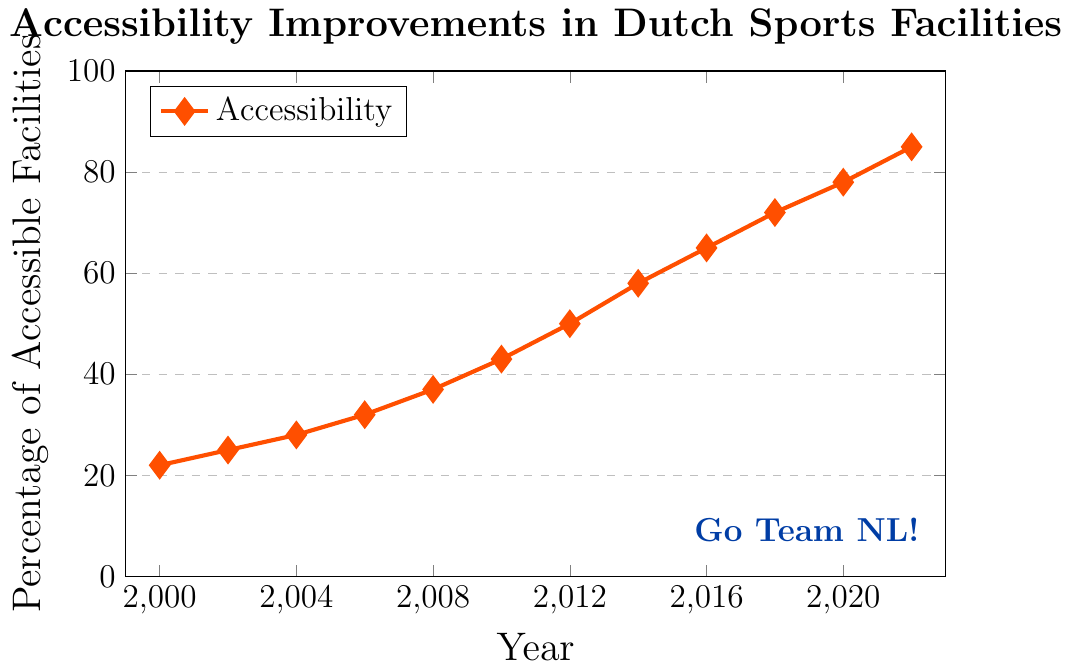What's the percentage increase in accessible sports facilities from 2000 to 2022? First, find the percentage of accessible sports facilities in 2000, which is 22%. Next, find the percentage in 2022, which is 85%. Subtract the 2000 value from the 2022 value to get the increase: 85 - 22 = 63.
Answer: 63 What is the average percentage of accessible sports facilities for the years 2000, 2010, and 2020? Find the percentages for the years 2000, 2010, and 2020: 22%, 43%, and 78%. Sum them up: 22 + 43 + 78 = 143. There are 3 years, so divide the total by 3 for the average: 143 / 3 ≈ 47.67.
Answer: 47.67 Which year had the highest percentage increase in accessible sports facilities compared to the previous data point? Calculate the year-on-year increases: 2002-2000: 25-22=3, 2004-2002: 28-25=3, 2006-2004: 32-28=4, 2008-2006: 37-32=5, 2010-2008: 43-37=6, 2012-2010: 50-43=7, 2014-2012: 58-50=8, 2016-2014: 65-58=7, 2018-2016: 72-65=7, 2020-2018: 78-72=6, 2022-2020: 85-78=7. The highest increase is from 2014 to 2016, with an increase of 8.
Answer: 2014 to 2016 What is the percentage difference in accessible facilities between 2012 and 2008? Find the percentages for 2012 and 2008: 50% and 37%. Subtract the 2008 value from the 2012 value: 50 - 37 = 13.
Answer: 13 By how much did the percentage of accessible sports facilities change from 2006 to 2008? Find the percentages for 2006 and 2008, which are 32% and 37%. Subtract the 2006 value from the 2008 value to get the change: 37 - 32 = 5.
Answer: 5 Was the percentage of accessible sports facilities ever the same in any two years? Go through the data points: none of the data points have the same percentage in different years. So, the percentages were never the same in any two years.
Answer: No What is the visual color used for the line representing the accessibility data? Observe the color of the line in the plot, which appears to be orange.
Answer: Orange Between which consecutive years did the percentage of accessible facilities exceed 50%? Identify the years when the percentage of accessible facilities first exceeded 50%: from 2012 (50%) to 2014 (58%).
Answer: 2012 to 2014 How did the general trend in accessibility improvements change from 2000 to 2022? By examining the dataset, it is clear that there is a steady upward trend in the percentage of accessible sports facilities, consistently increasing year-by-year.
Answer: Increasing What is the difference in the highest and lowest recorded percentages of accessible sports facilities from 2000 to 2022? Identify the highest percentage (85% in 2022) and the lowest percentage (22% in 2000). Subtract the lowest from the highest to get the difference: 85 - 22 = 63.
Answer: 63 